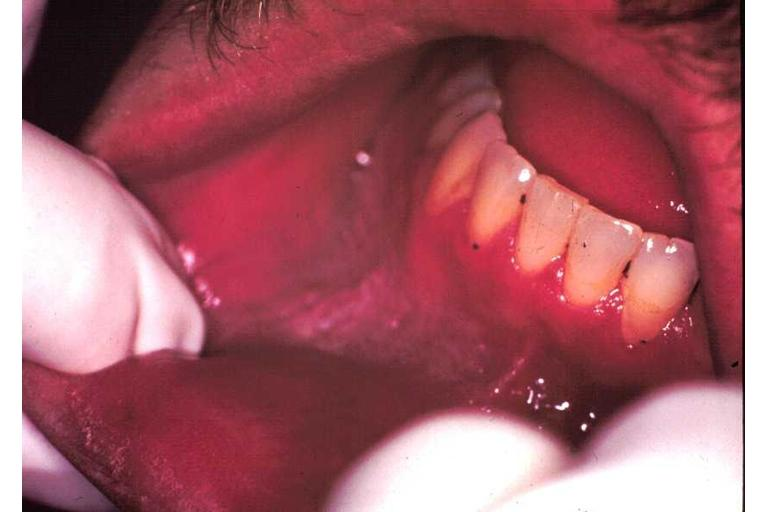does this image show leukoplakia?
Answer the question using a single word or phrase. Yes 